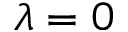Convert formula to latex. <formula><loc_0><loc_0><loc_500><loc_500>\lambda = 0</formula> 